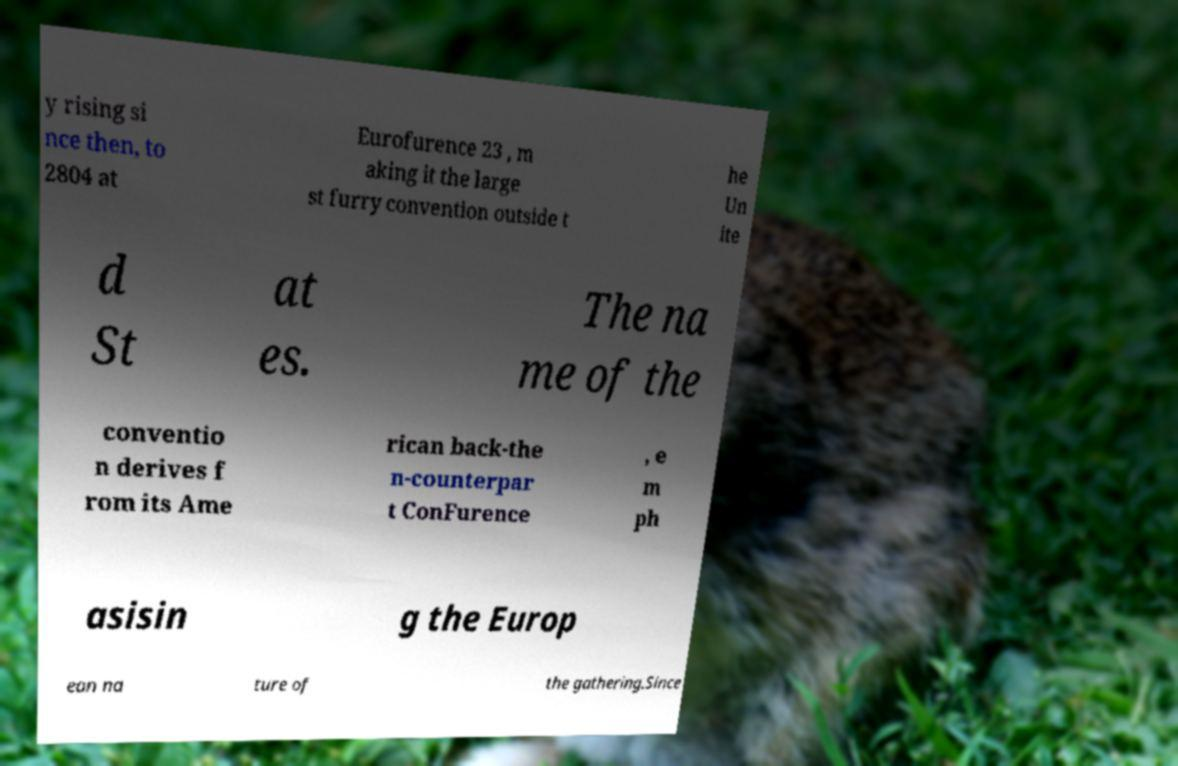Can you accurately transcribe the text from the provided image for me? y rising si nce then, to 2804 at Eurofurence 23 , m aking it the large st furry convention outside t he Un ite d St at es. The na me of the conventio n derives f rom its Ame rican back-the n-counterpar t ConFurence , e m ph asisin g the Europ ean na ture of the gathering.Since 